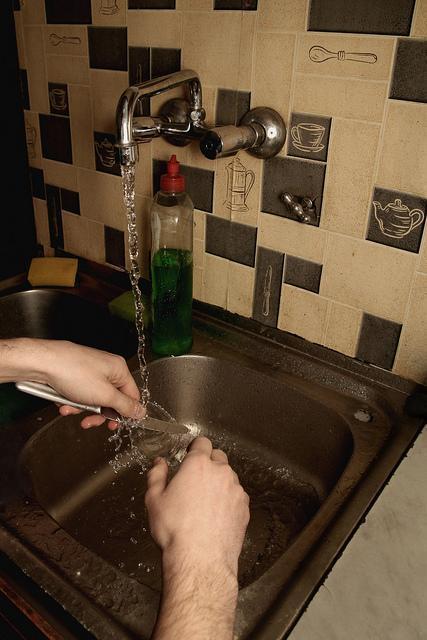How many blue skis are there?
Give a very brief answer. 0. 